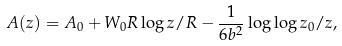Convert formula to latex. <formula><loc_0><loc_0><loc_500><loc_500>A ( z ) = A _ { 0 } + W _ { 0 } R \log { z / R } - \frac { 1 } { 6 b ^ { 2 } } \log { \log { z _ { 0 } / z } } ,</formula> 